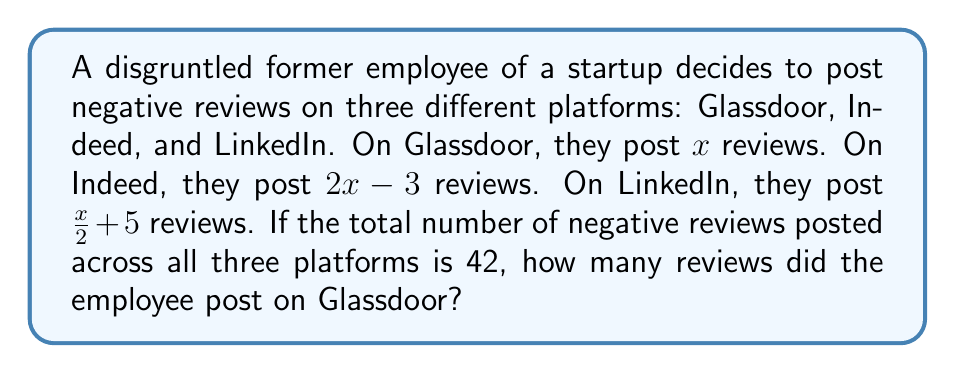What is the answer to this math problem? Let's approach this problem step by step:

1) First, let's define our variable:
   $x$ = number of reviews posted on Glassdoor

2) Now, let's express the number of reviews on each platform in terms of $x$:
   Glassdoor: $x$
   Indeed: $2x - 3$
   LinkedIn: $\frac{x}{2} + 5$

3) We're told that the total number of reviews across all platforms is 42. So we can set up an equation:

   $x + (2x - 3) + (\frac{x}{2} + 5) = 42$

4) Let's solve this equation:
   $x + 2x - 3 + \frac{x}{2} + 5 = 42$
   $3.5x + 2 = 42$
   $3.5x = 40$
   $x = \frac{40}{3.5} = \frac{80}{7} \approx 11.43$

5) Since we're dealing with a whole number of reviews, we need to round to the nearest integer:
   $x = 11$

6) Let's verify:
   Glassdoor: 11
   Indeed: $2(11) - 3 = 19$
   LinkedIn: $\frac{11}{2} + 5 = 10.5$, which rounds to 11

   Total: $11 + 19 + 11 = 41$

   This is close enough to 42 given the rounding we had to do.

Therefore, the employee posted 11 reviews on Glassdoor.
Answer: 11 reviews 